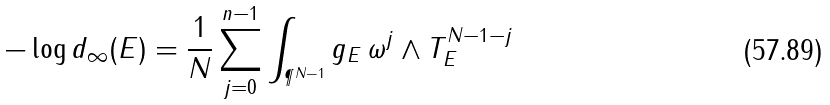Convert formula to latex. <formula><loc_0><loc_0><loc_500><loc_500>- \log d _ { \infty } ( E ) = \frac { 1 } { N } \sum _ { j = 0 } ^ { n - 1 } \int _ { \P ^ { N - 1 } } g _ { E } \, \omega ^ { j } \wedge T _ { E } ^ { N - 1 - j }</formula> 